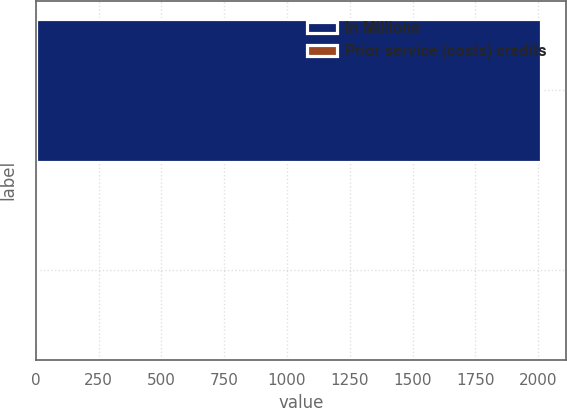Convert chart to OTSL. <chart><loc_0><loc_0><loc_500><loc_500><bar_chart><fcel>In Millions<fcel>Prior service (costs) credits<nl><fcel>2012<fcel>7.2<nl></chart> 